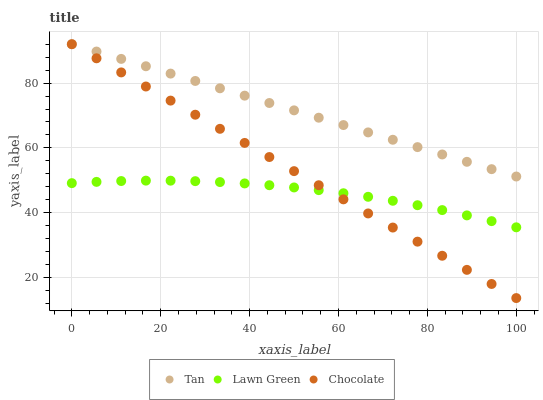Does Lawn Green have the minimum area under the curve?
Answer yes or no. Yes. Does Tan have the maximum area under the curve?
Answer yes or no. Yes. Does Chocolate have the minimum area under the curve?
Answer yes or no. No. Does Chocolate have the maximum area under the curve?
Answer yes or no. No. Is Tan the smoothest?
Answer yes or no. Yes. Is Lawn Green the roughest?
Answer yes or no. Yes. Is Chocolate the smoothest?
Answer yes or no. No. Is Chocolate the roughest?
Answer yes or no. No. Does Chocolate have the lowest value?
Answer yes or no. Yes. Does Tan have the lowest value?
Answer yes or no. No. Does Chocolate have the highest value?
Answer yes or no. Yes. Is Lawn Green less than Tan?
Answer yes or no. Yes. Is Tan greater than Lawn Green?
Answer yes or no. Yes. Does Chocolate intersect Tan?
Answer yes or no. Yes. Is Chocolate less than Tan?
Answer yes or no. No. Is Chocolate greater than Tan?
Answer yes or no. No. Does Lawn Green intersect Tan?
Answer yes or no. No. 